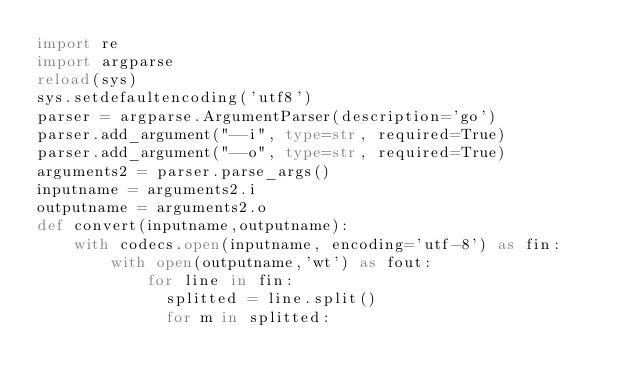Convert code to text. <code><loc_0><loc_0><loc_500><loc_500><_Python_>import re
import argparse
reload(sys)
sys.setdefaultencoding('utf8')
parser = argparse.ArgumentParser(description='go')
parser.add_argument("--i", type=str, required=True)
parser.add_argument("--o", type=str, required=True)
arguments2 = parser.parse_args()
inputname = arguments2.i
outputname = arguments2.o
def convert(inputname,outputname):
    with codecs.open(inputname, encoding='utf-8') as fin:
        with open(outputname,'wt') as fout:
            for line in fin:
            	splitted = line.split()
            	for m in splitted:</code> 